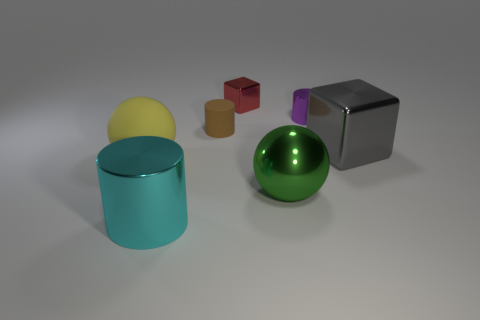Are there fewer red cubes behind the red metal thing than big blue matte cylinders?
Your response must be concise. No. Is the small brown matte thing the same shape as the large yellow matte object?
Your answer should be very brief. No. Are any brown rubber cylinders visible?
Give a very brief answer. Yes. Is the shape of the cyan object the same as the matte object that is to the right of the yellow rubber sphere?
Your answer should be very brief. Yes. What is the material of the purple cylinder right of the metal cube behind the brown rubber cylinder?
Keep it short and to the point. Metal. What color is the tiny metal block?
Keep it short and to the point. Red. What size is the other metallic object that is the same shape as the gray shiny object?
Your answer should be very brief. Small. What number of small rubber cylinders have the same color as the tiny metal cylinder?
Give a very brief answer. 0. What number of things are balls that are to the left of the big metallic cylinder or brown matte cylinders?
Your answer should be very brief. 2. There is a tiny cylinder that is made of the same material as the big gray block; what is its color?
Your answer should be compact. Purple. 